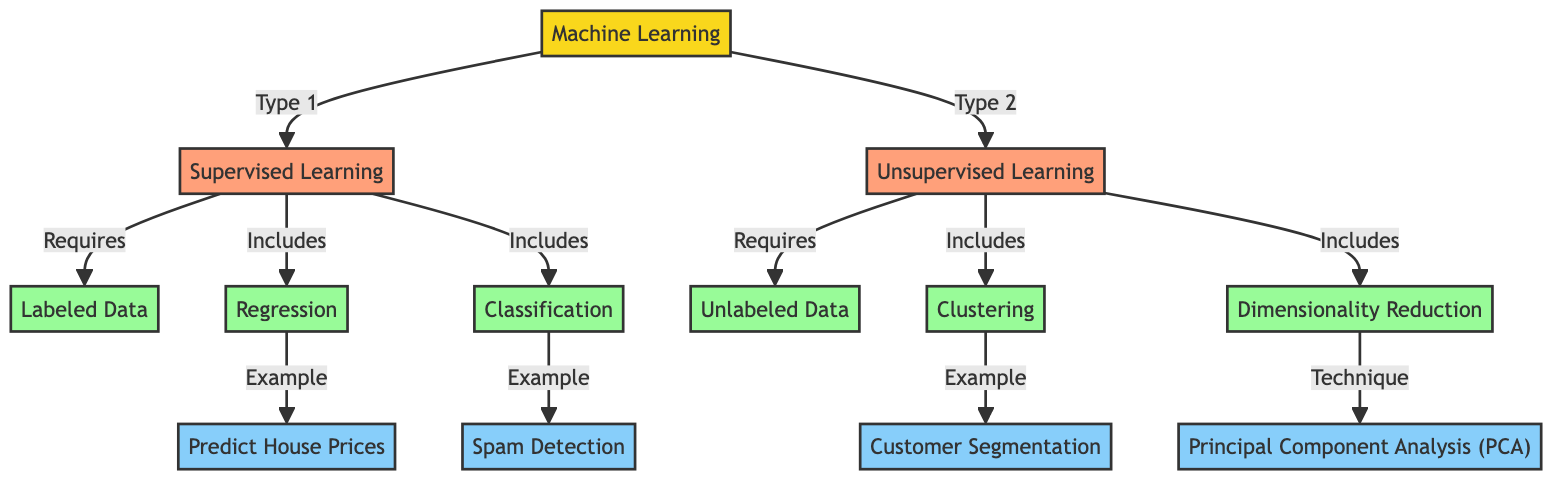What are the two main types of machine learning shown in the diagram? The diagram identifies two main types of machine learning, which are Supervised Learning and Unsupervised Learning. These are explicitly labeled as the second and third nodes in the diagram.
Answer: Supervised Learning, Unsupervised Learning What data type does supervised learning require? The diagram specifies that Supervised Learning requires Labeled Data, which is indicated by the directed edge from Supervised Learning to Labeled Data.
Answer: Labeled Data What data type does unsupervised learning require? According to the diagram, Unsupervised Learning requires Unlabeled Data. This relationship is shown as a direct connection from Unsupervised Learning to Unlabeled Data.
Answer: Unlabeled Data How many examples of supervised learning are provided in the diagram? The diagram provides two examples of supervised learning: Predict House Prices and Spam Detection. By counting the edges from the Supervised Learning node to both examples, we find a total of two.
Answer: 2 What is one technique listed under unsupervised learning? The diagram includes Principal Component Analysis (PCA) as a technique for unsupervised learning. This is clearly labeled as connected to the Unsupervised Learning node and falls under the Dimensionality Reduction type.
Answer: Principal Component Analysis (PCA) Which type of learning includes clustering and dimensionality reduction? The diagram indicates that Unsupervised Learning includes both Clustering and Dimensionality Reduction. These are represented as subtypes connected to the Unsupervised Learning node.
Answer: Unsupervised Learning What is the example given for regression in the diagram? The example associated with regression provided in the diagram is Predict House Prices. This example is linked specifically to the Regression subtype under Supervised Learning.
Answer: Predict House Prices Name a use case for classification based on the diagram. The diagram states that Spam Detection serves as an example of a use case for classification. It visually connects to the Classification subtype under Supervised Learning.
Answer: Spam Detection Which learning type is represented by customer segmentation? Customer Segmentation is identified as an example of Unsupervised Learning. This relationship is shown as an edge linking Customer Segmentation to the Clustering subtype under Unsupervised Learning.
Answer: Unsupervised Learning 